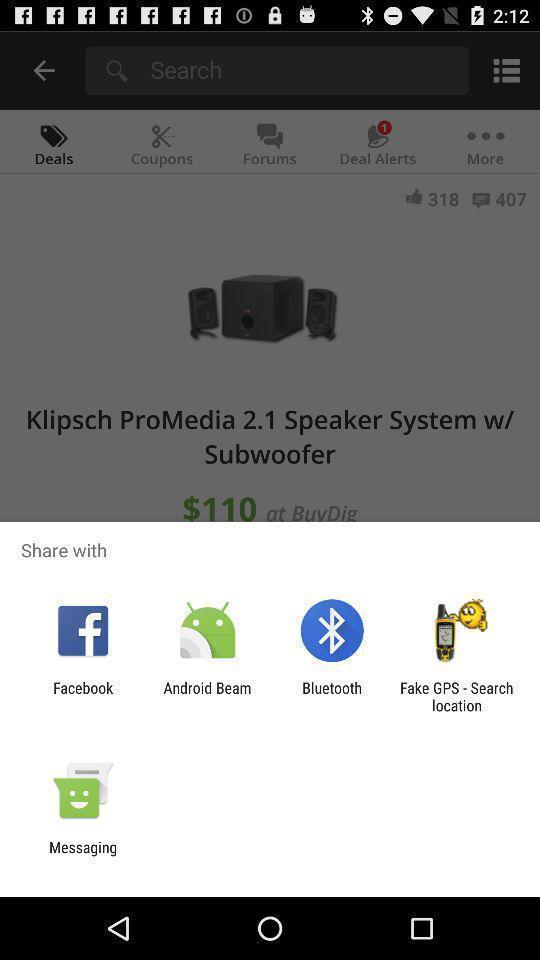Explain the elements present in this screenshot. Popup to share product details in the shopping app. 